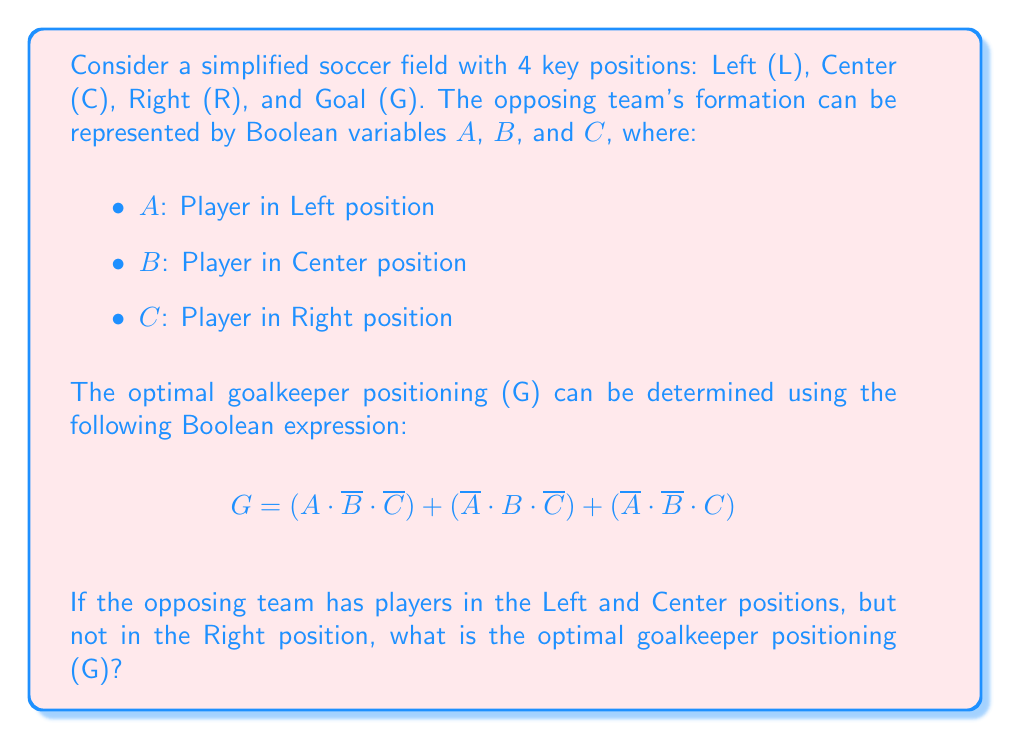Help me with this question. Let's approach this step-by-step:

1) We're given that there are players in the Left and Center positions, but not in the Right position. This means:
   $A = 1$ (player in Left)
   $B = 1$ (player in Center)
   $C = 0$ (no player in Right)

2) Let's substitute these values into our Boolean expression:

   $G = (A \cdot \overline{B} \cdot \overline{C}) + (\overline{A} \cdot B \cdot \overline{C}) + (\overline{A} \cdot \overline{B} \cdot C)$

3) Substituting the values:

   $G = (1 \cdot \overline{1} \cdot \overline{0}) + (\overline{1} \cdot 1 \cdot \overline{0}) + (\overline{1} \cdot \overline{1} \cdot 0)$

4) Simplify the negations:
   $\overline{1} = 0$
   $\overline{0} = 1$

   $G = (1 \cdot 0 \cdot 1) + (0 \cdot 1 \cdot 1) + (0 \cdot 0 \cdot 0)$

5) Evaluate each term:
   $(1 \cdot 0 \cdot 1) = 0$
   $(0 \cdot 1 \cdot 1) = 0$
   $(0 \cdot 0 \cdot 0) = 0$

6) Sum the terms:

   $G = 0 + 0 + 0 = 0$

Therefore, the optimal goalkeeper positioning (G) is 0, which in this context means the goalkeeper should not be in an extreme position.
Answer: $G = 0$ 